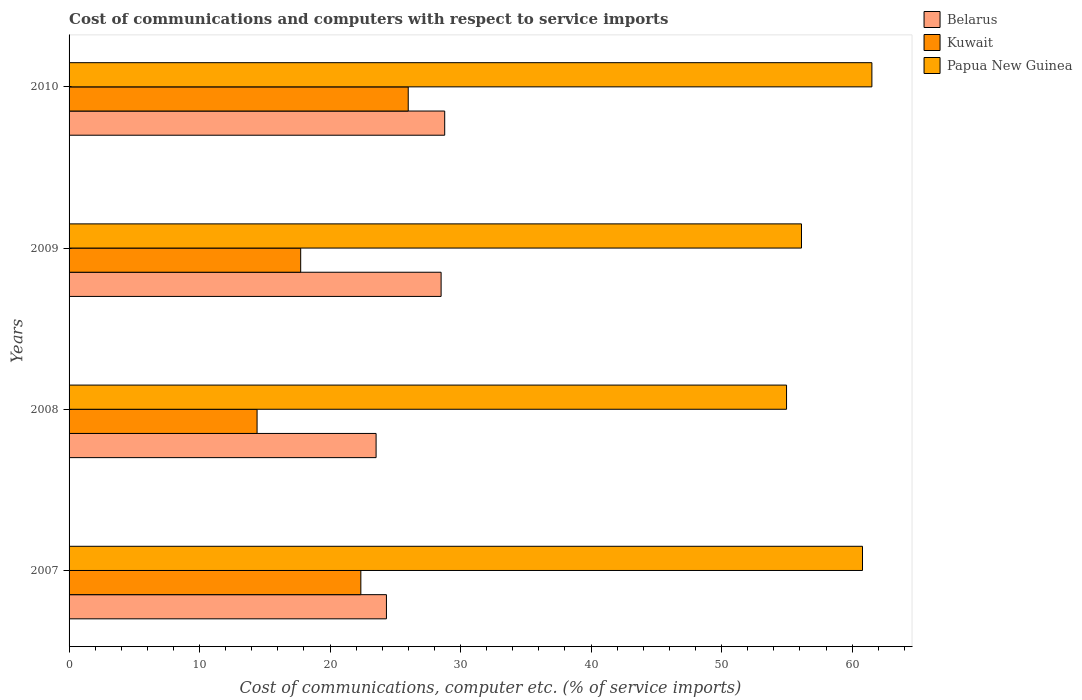How many different coloured bars are there?
Keep it short and to the point. 3. How many groups of bars are there?
Ensure brevity in your answer.  4. Are the number of bars per tick equal to the number of legend labels?
Offer a very short reply. Yes. Are the number of bars on each tick of the Y-axis equal?
Your response must be concise. Yes. How many bars are there on the 1st tick from the top?
Ensure brevity in your answer.  3. What is the label of the 3rd group of bars from the top?
Offer a very short reply. 2008. In how many cases, is the number of bars for a given year not equal to the number of legend labels?
Offer a very short reply. 0. What is the cost of communications and computers in Kuwait in 2010?
Give a very brief answer. 25.99. Across all years, what is the maximum cost of communications and computers in Kuwait?
Your answer should be very brief. 25.99. Across all years, what is the minimum cost of communications and computers in Belarus?
Your response must be concise. 23.53. In which year was the cost of communications and computers in Papua New Guinea maximum?
Your response must be concise. 2010. In which year was the cost of communications and computers in Papua New Guinea minimum?
Keep it short and to the point. 2008. What is the total cost of communications and computers in Belarus in the graph?
Your response must be concise. 105.14. What is the difference between the cost of communications and computers in Papua New Guinea in 2008 and that in 2010?
Offer a terse response. -6.54. What is the difference between the cost of communications and computers in Belarus in 2009 and the cost of communications and computers in Kuwait in 2007?
Provide a succinct answer. 6.15. What is the average cost of communications and computers in Papua New Guinea per year?
Your answer should be very brief. 58.35. In the year 2010, what is the difference between the cost of communications and computers in Belarus and cost of communications and computers in Papua New Guinea?
Your answer should be very brief. -32.73. What is the ratio of the cost of communications and computers in Belarus in 2008 to that in 2010?
Offer a very short reply. 0.82. Is the difference between the cost of communications and computers in Belarus in 2007 and 2008 greater than the difference between the cost of communications and computers in Papua New Guinea in 2007 and 2008?
Your response must be concise. No. What is the difference between the highest and the second highest cost of communications and computers in Kuwait?
Make the answer very short. 3.63. What is the difference between the highest and the lowest cost of communications and computers in Kuwait?
Make the answer very short. 11.58. What does the 1st bar from the top in 2008 represents?
Your response must be concise. Papua New Guinea. What does the 3rd bar from the bottom in 2009 represents?
Provide a short and direct response. Papua New Guinea. Is it the case that in every year, the sum of the cost of communications and computers in Belarus and cost of communications and computers in Papua New Guinea is greater than the cost of communications and computers in Kuwait?
Make the answer very short. Yes. How many bars are there?
Ensure brevity in your answer.  12. How many years are there in the graph?
Give a very brief answer. 4. Does the graph contain grids?
Your answer should be very brief. No. How many legend labels are there?
Ensure brevity in your answer.  3. How are the legend labels stacked?
Your response must be concise. Vertical. What is the title of the graph?
Your answer should be very brief. Cost of communications and computers with respect to service imports. What is the label or title of the X-axis?
Give a very brief answer. Cost of communications, computer etc. (% of service imports). What is the Cost of communications, computer etc. (% of service imports) of Belarus in 2007?
Give a very brief answer. 24.32. What is the Cost of communications, computer etc. (% of service imports) of Kuwait in 2007?
Your answer should be very brief. 22.36. What is the Cost of communications, computer etc. (% of service imports) of Papua New Guinea in 2007?
Your response must be concise. 60.8. What is the Cost of communications, computer etc. (% of service imports) in Belarus in 2008?
Provide a short and direct response. 23.53. What is the Cost of communications, computer etc. (% of service imports) of Kuwait in 2008?
Your response must be concise. 14.41. What is the Cost of communications, computer etc. (% of service imports) of Papua New Guinea in 2008?
Your answer should be very brief. 54.98. What is the Cost of communications, computer etc. (% of service imports) in Belarus in 2009?
Your response must be concise. 28.51. What is the Cost of communications, computer etc. (% of service imports) in Kuwait in 2009?
Ensure brevity in your answer.  17.75. What is the Cost of communications, computer etc. (% of service imports) in Papua New Guinea in 2009?
Offer a terse response. 56.12. What is the Cost of communications, computer etc. (% of service imports) in Belarus in 2010?
Keep it short and to the point. 28.78. What is the Cost of communications, computer etc. (% of service imports) of Kuwait in 2010?
Provide a short and direct response. 25.99. What is the Cost of communications, computer etc. (% of service imports) of Papua New Guinea in 2010?
Keep it short and to the point. 61.52. Across all years, what is the maximum Cost of communications, computer etc. (% of service imports) in Belarus?
Your answer should be very brief. 28.78. Across all years, what is the maximum Cost of communications, computer etc. (% of service imports) in Kuwait?
Keep it short and to the point. 25.99. Across all years, what is the maximum Cost of communications, computer etc. (% of service imports) in Papua New Guinea?
Your answer should be compact. 61.52. Across all years, what is the minimum Cost of communications, computer etc. (% of service imports) in Belarus?
Your answer should be compact. 23.53. Across all years, what is the minimum Cost of communications, computer etc. (% of service imports) in Kuwait?
Your answer should be compact. 14.41. Across all years, what is the minimum Cost of communications, computer etc. (% of service imports) in Papua New Guinea?
Provide a short and direct response. 54.98. What is the total Cost of communications, computer etc. (% of service imports) in Belarus in the graph?
Make the answer very short. 105.14. What is the total Cost of communications, computer etc. (% of service imports) in Kuwait in the graph?
Offer a very short reply. 80.5. What is the total Cost of communications, computer etc. (% of service imports) in Papua New Guinea in the graph?
Offer a terse response. 233.41. What is the difference between the Cost of communications, computer etc. (% of service imports) of Belarus in 2007 and that in 2008?
Make the answer very short. 0.79. What is the difference between the Cost of communications, computer etc. (% of service imports) of Kuwait in 2007 and that in 2008?
Ensure brevity in your answer.  7.95. What is the difference between the Cost of communications, computer etc. (% of service imports) in Papua New Guinea in 2007 and that in 2008?
Your answer should be compact. 5.82. What is the difference between the Cost of communications, computer etc. (% of service imports) of Belarus in 2007 and that in 2009?
Your answer should be compact. -4.19. What is the difference between the Cost of communications, computer etc. (% of service imports) of Kuwait in 2007 and that in 2009?
Provide a short and direct response. 4.61. What is the difference between the Cost of communications, computer etc. (% of service imports) in Papua New Guinea in 2007 and that in 2009?
Offer a very short reply. 4.68. What is the difference between the Cost of communications, computer etc. (% of service imports) in Belarus in 2007 and that in 2010?
Ensure brevity in your answer.  -4.46. What is the difference between the Cost of communications, computer etc. (% of service imports) in Kuwait in 2007 and that in 2010?
Give a very brief answer. -3.63. What is the difference between the Cost of communications, computer etc. (% of service imports) of Papua New Guinea in 2007 and that in 2010?
Keep it short and to the point. -0.72. What is the difference between the Cost of communications, computer etc. (% of service imports) in Belarus in 2008 and that in 2009?
Offer a terse response. -4.98. What is the difference between the Cost of communications, computer etc. (% of service imports) of Kuwait in 2008 and that in 2009?
Provide a succinct answer. -3.34. What is the difference between the Cost of communications, computer etc. (% of service imports) of Papua New Guinea in 2008 and that in 2009?
Provide a succinct answer. -1.14. What is the difference between the Cost of communications, computer etc. (% of service imports) in Belarus in 2008 and that in 2010?
Offer a terse response. -5.26. What is the difference between the Cost of communications, computer etc. (% of service imports) in Kuwait in 2008 and that in 2010?
Your response must be concise. -11.58. What is the difference between the Cost of communications, computer etc. (% of service imports) of Papua New Guinea in 2008 and that in 2010?
Offer a terse response. -6.54. What is the difference between the Cost of communications, computer etc. (% of service imports) in Belarus in 2009 and that in 2010?
Offer a very short reply. -0.28. What is the difference between the Cost of communications, computer etc. (% of service imports) in Kuwait in 2009 and that in 2010?
Your answer should be very brief. -8.24. What is the difference between the Cost of communications, computer etc. (% of service imports) of Papua New Guinea in 2009 and that in 2010?
Keep it short and to the point. -5.4. What is the difference between the Cost of communications, computer etc. (% of service imports) of Belarus in 2007 and the Cost of communications, computer etc. (% of service imports) of Kuwait in 2008?
Make the answer very short. 9.91. What is the difference between the Cost of communications, computer etc. (% of service imports) of Belarus in 2007 and the Cost of communications, computer etc. (% of service imports) of Papua New Guinea in 2008?
Provide a short and direct response. -30.66. What is the difference between the Cost of communications, computer etc. (% of service imports) in Kuwait in 2007 and the Cost of communications, computer etc. (% of service imports) in Papua New Guinea in 2008?
Your answer should be very brief. -32.62. What is the difference between the Cost of communications, computer etc. (% of service imports) of Belarus in 2007 and the Cost of communications, computer etc. (% of service imports) of Kuwait in 2009?
Make the answer very short. 6.57. What is the difference between the Cost of communications, computer etc. (% of service imports) of Belarus in 2007 and the Cost of communications, computer etc. (% of service imports) of Papua New Guinea in 2009?
Keep it short and to the point. -31.8. What is the difference between the Cost of communications, computer etc. (% of service imports) of Kuwait in 2007 and the Cost of communications, computer etc. (% of service imports) of Papua New Guinea in 2009?
Your response must be concise. -33.76. What is the difference between the Cost of communications, computer etc. (% of service imports) of Belarus in 2007 and the Cost of communications, computer etc. (% of service imports) of Kuwait in 2010?
Make the answer very short. -1.67. What is the difference between the Cost of communications, computer etc. (% of service imports) of Belarus in 2007 and the Cost of communications, computer etc. (% of service imports) of Papua New Guinea in 2010?
Give a very brief answer. -37.2. What is the difference between the Cost of communications, computer etc. (% of service imports) of Kuwait in 2007 and the Cost of communications, computer etc. (% of service imports) of Papua New Guinea in 2010?
Your response must be concise. -39.16. What is the difference between the Cost of communications, computer etc. (% of service imports) of Belarus in 2008 and the Cost of communications, computer etc. (% of service imports) of Kuwait in 2009?
Offer a terse response. 5.78. What is the difference between the Cost of communications, computer etc. (% of service imports) of Belarus in 2008 and the Cost of communications, computer etc. (% of service imports) of Papua New Guinea in 2009?
Provide a succinct answer. -32.59. What is the difference between the Cost of communications, computer etc. (% of service imports) of Kuwait in 2008 and the Cost of communications, computer etc. (% of service imports) of Papua New Guinea in 2009?
Your answer should be compact. -41.72. What is the difference between the Cost of communications, computer etc. (% of service imports) of Belarus in 2008 and the Cost of communications, computer etc. (% of service imports) of Kuwait in 2010?
Keep it short and to the point. -2.46. What is the difference between the Cost of communications, computer etc. (% of service imports) in Belarus in 2008 and the Cost of communications, computer etc. (% of service imports) in Papua New Guinea in 2010?
Give a very brief answer. -37.99. What is the difference between the Cost of communications, computer etc. (% of service imports) in Kuwait in 2008 and the Cost of communications, computer etc. (% of service imports) in Papua New Guinea in 2010?
Your response must be concise. -47.11. What is the difference between the Cost of communications, computer etc. (% of service imports) in Belarus in 2009 and the Cost of communications, computer etc. (% of service imports) in Kuwait in 2010?
Make the answer very short. 2.52. What is the difference between the Cost of communications, computer etc. (% of service imports) in Belarus in 2009 and the Cost of communications, computer etc. (% of service imports) in Papua New Guinea in 2010?
Ensure brevity in your answer.  -33.01. What is the difference between the Cost of communications, computer etc. (% of service imports) of Kuwait in 2009 and the Cost of communications, computer etc. (% of service imports) of Papua New Guinea in 2010?
Provide a succinct answer. -43.77. What is the average Cost of communications, computer etc. (% of service imports) of Belarus per year?
Your answer should be compact. 26.28. What is the average Cost of communications, computer etc. (% of service imports) of Kuwait per year?
Offer a very short reply. 20.12. What is the average Cost of communications, computer etc. (% of service imports) of Papua New Guinea per year?
Offer a terse response. 58.35. In the year 2007, what is the difference between the Cost of communications, computer etc. (% of service imports) in Belarus and Cost of communications, computer etc. (% of service imports) in Kuwait?
Ensure brevity in your answer.  1.96. In the year 2007, what is the difference between the Cost of communications, computer etc. (% of service imports) of Belarus and Cost of communications, computer etc. (% of service imports) of Papua New Guinea?
Give a very brief answer. -36.48. In the year 2007, what is the difference between the Cost of communications, computer etc. (% of service imports) in Kuwait and Cost of communications, computer etc. (% of service imports) in Papua New Guinea?
Keep it short and to the point. -38.44. In the year 2008, what is the difference between the Cost of communications, computer etc. (% of service imports) in Belarus and Cost of communications, computer etc. (% of service imports) in Kuwait?
Your response must be concise. 9.12. In the year 2008, what is the difference between the Cost of communications, computer etc. (% of service imports) of Belarus and Cost of communications, computer etc. (% of service imports) of Papua New Guinea?
Ensure brevity in your answer.  -31.45. In the year 2008, what is the difference between the Cost of communications, computer etc. (% of service imports) in Kuwait and Cost of communications, computer etc. (% of service imports) in Papua New Guinea?
Your answer should be very brief. -40.57. In the year 2009, what is the difference between the Cost of communications, computer etc. (% of service imports) of Belarus and Cost of communications, computer etc. (% of service imports) of Kuwait?
Your answer should be compact. 10.76. In the year 2009, what is the difference between the Cost of communications, computer etc. (% of service imports) of Belarus and Cost of communications, computer etc. (% of service imports) of Papua New Guinea?
Ensure brevity in your answer.  -27.61. In the year 2009, what is the difference between the Cost of communications, computer etc. (% of service imports) in Kuwait and Cost of communications, computer etc. (% of service imports) in Papua New Guinea?
Your answer should be very brief. -38.37. In the year 2010, what is the difference between the Cost of communications, computer etc. (% of service imports) of Belarus and Cost of communications, computer etc. (% of service imports) of Kuwait?
Keep it short and to the point. 2.79. In the year 2010, what is the difference between the Cost of communications, computer etc. (% of service imports) in Belarus and Cost of communications, computer etc. (% of service imports) in Papua New Guinea?
Make the answer very short. -32.73. In the year 2010, what is the difference between the Cost of communications, computer etc. (% of service imports) in Kuwait and Cost of communications, computer etc. (% of service imports) in Papua New Guinea?
Your answer should be compact. -35.53. What is the ratio of the Cost of communications, computer etc. (% of service imports) of Belarus in 2007 to that in 2008?
Your answer should be compact. 1.03. What is the ratio of the Cost of communications, computer etc. (% of service imports) in Kuwait in 2007 to that in 2008?
Provide a short and direct response. 1.55. What is the ratio of the Cost of communications, computer etc. (% of service imports) in Papua New Guinea in 2007 to that in 2008?
Keep it short and to the point. 1.11. What is the ratio of the Cost of communications, computer etc. (% of service imports) in Belarus in 2007 to that in 2009?
Your answer should be compact. 0.85. What is the ratio of the Cost of communications, computer etc. (% of service imports) of Kuwait in 2007 to that in 2009?
Your response must be concise. 1.26. What is the ratio of the Cost of communications, computer etc. (% of service imports) in Belarus in 2007 to that in 2010?
Offer a very short reply. 0.84. What is the ratio of the Cost of communications, computer etc. (% of service imports) of Kuwait in 2007 to that in 2010?
Keep it short and to the point. 0.86. What is the ratio of the Cost of communications, computer etc. (% of service imports) in Papua New Guinea in 2007 to that in 2010?
Offer a terse response. 0.99. What is the ratio of the Cost of communications, computer etc. (% of service imports) in Belarus in 2008 to that in 2009?
Offer a terse response. 0.83. What is the ratio of the Cost of communications, computer etc. (% of service imports) in Kuwait in 2008 to that in 2009?
Make the answer very short. 0.81. What is the ratio of the Cost of communications, computer etc. (% of service imports) in Papua New Guinea in 2008 to that in 2009?
Your response must be concise. 0.98. What is the ratio of the Cost of communications, computer etc. (% of service imports) in Belarus in 2008 to that in 2010?
Keep it short and to the point. 0.82. What is the ratio of the Cost of communications, computer etc. (% of service imports) in Kuwait in 2008 to that in 2010?
Keep it short and to the point. 0.55. What is the ratio of the Cost of communications, computer etc. (% of service imports) of Papua New Guinea in 2008 to that in 2010?
Keep it short and to the point. 0.89. What is the ratio of the Cost of communications, computer etc. (% of service imports) in Kuwait in 2009 to that in 2010?
Your answer should be compact. 0.68. What is the ratio of the Cost of communications, computer etc. (% of service imports) in Papua New Guinea in 2009 to that in 2010?
Ensure brevity in your answer.  0.91. What is the difference between the highest and the second highest Cost of communications, computer etc. (% of service imports) in Belarus?
Provide a succinct answer. 0.28. What is the difference between the highest and the second highest Cost of communications, computer etc. (% of service imports) in Kuwait?
Offer a terse response. 3.63. What is the difference between the highest and the second highest Cost of communications, computer etc. (% of service imports) in Papua New Guinea?
Your answer should be compact. 0.72. What is the difference between the highest and the lowest Cost of communications, computer etc. (% of service imports) of Belarus?
Give a very brief answer. 5.26. What is the difference between the highest and the lowest Cost of communications, computer etc. (% of service imports) of Kuwait?
Offer a very short reply. 11.58. What is the difference between the highest and the lowest Cost of communications, computer etc. (% of service imports) of Papua New Guinea?
Make the answer very short. 6.54. 